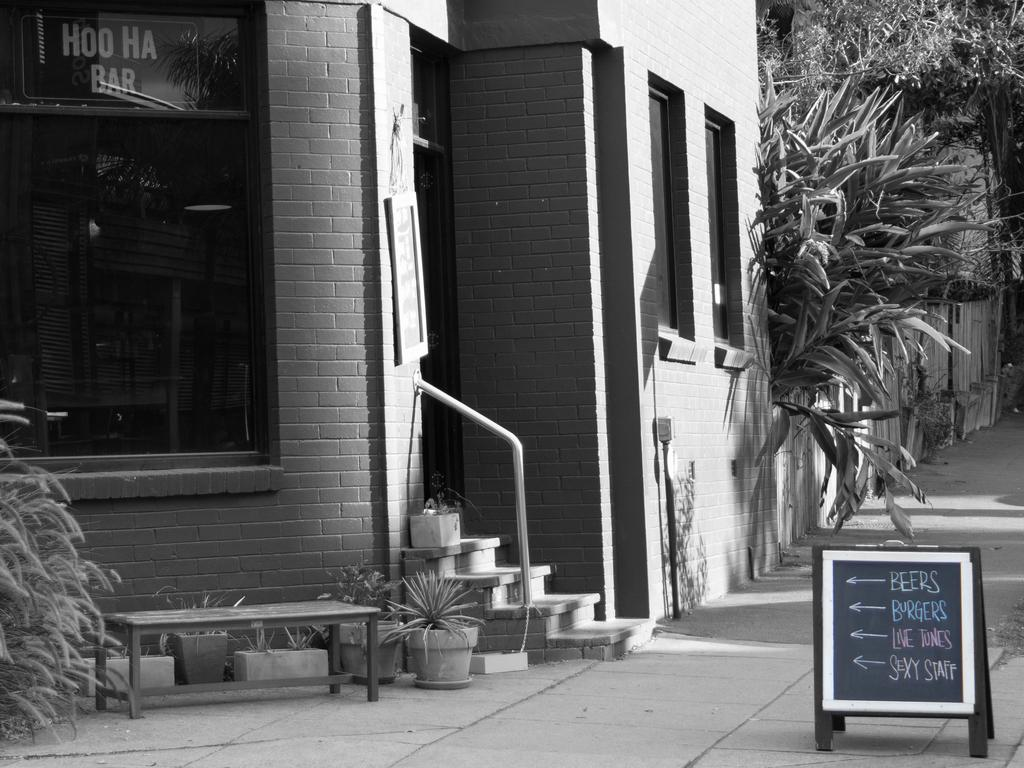What type of structure is visible in the image? There is a building in the image. What can be seen on the right side of the image? There are trees on the right side of the image. How is the image presented? The image is in black and white. What is located in front of the building? There is a board in front of the building. What is written on the board? There is writing on the board. Who is the manager of the attraction depicted in the image? There is no indication of an attraction or a manager in the image; it only shows a building, trees, and a board with writing. 